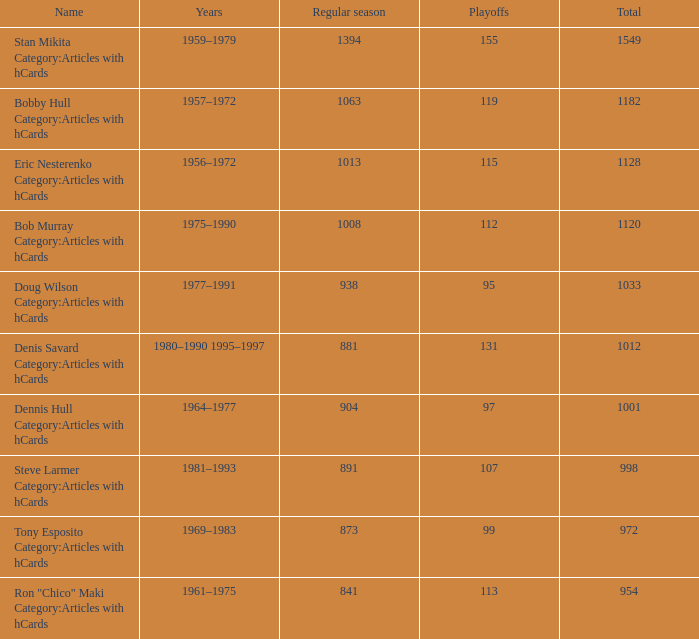How may times is regular season 1063 and playoffs more than 119? 0.0. 